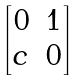<formula> <loc_0><loc_0><loc_500><loc_500>\begin{bmatrix} 0 & 1 \\ c & 0 \end{bmatrix}</formula> 